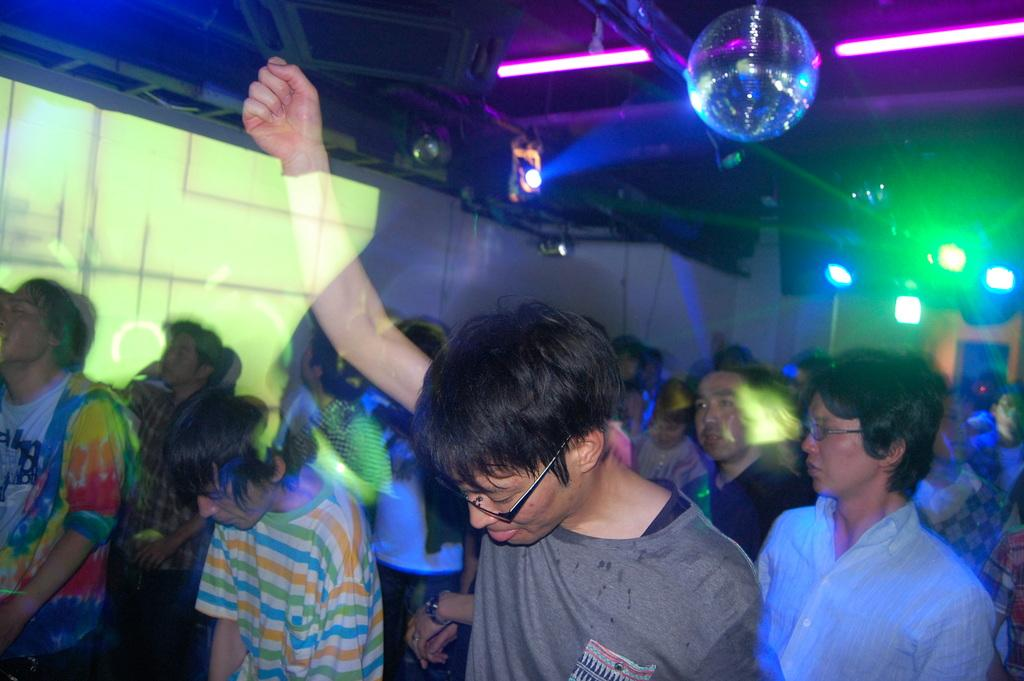Who or what can be seen in the image? There are people in the image. Where are the people located? The people are standing in a closed auditorium. What can be seen in the auditorium besides the people? There are lights visible in the image. What is visible in the background of the image? There is a wall in the background of the image. What type of rifle is being used by the people in the image? There is no rifle present in the image; it features people standing in a closed auditorium. Can you tell me how many spades are being used by the people in the image? There are no spades present in the image; the people are simply standing in the auditorium. 